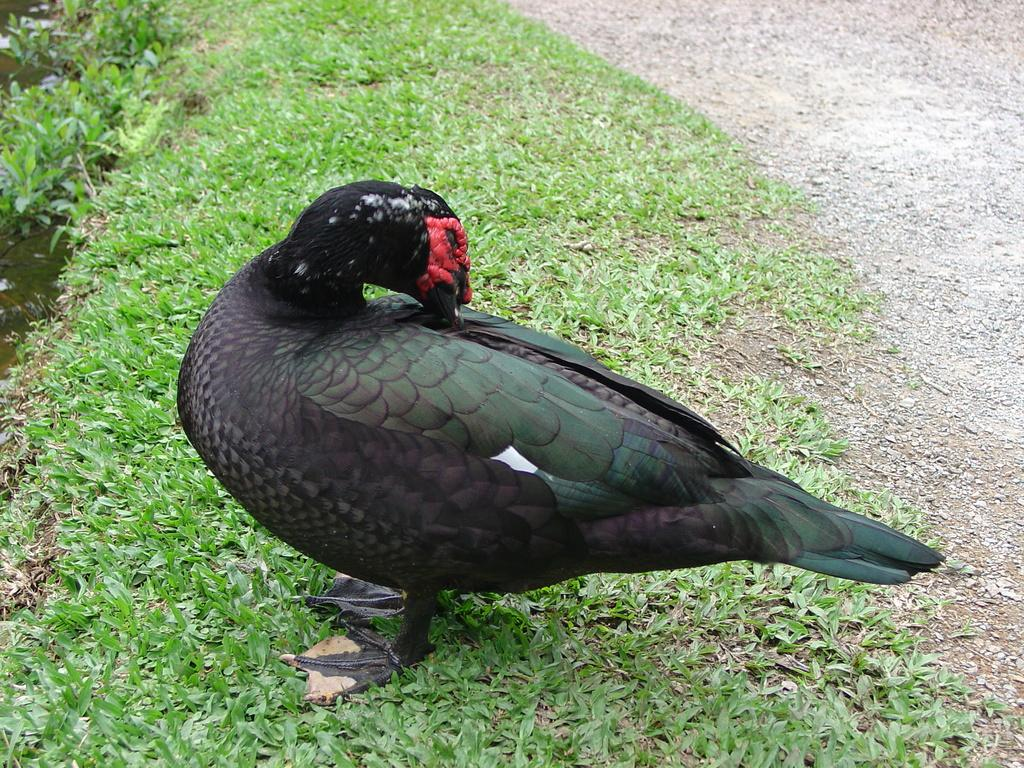What type of animal can be seen in the image? There is a bird in the image. Where is the bird located? The bird is on the surface of the grass. What else can be seen in the image besides the bird? There is water visible in the image. What color is the vein in the bird's wing in the image? There is no visible vein in the bird's wing in the image, and therefore no color can be determined. 